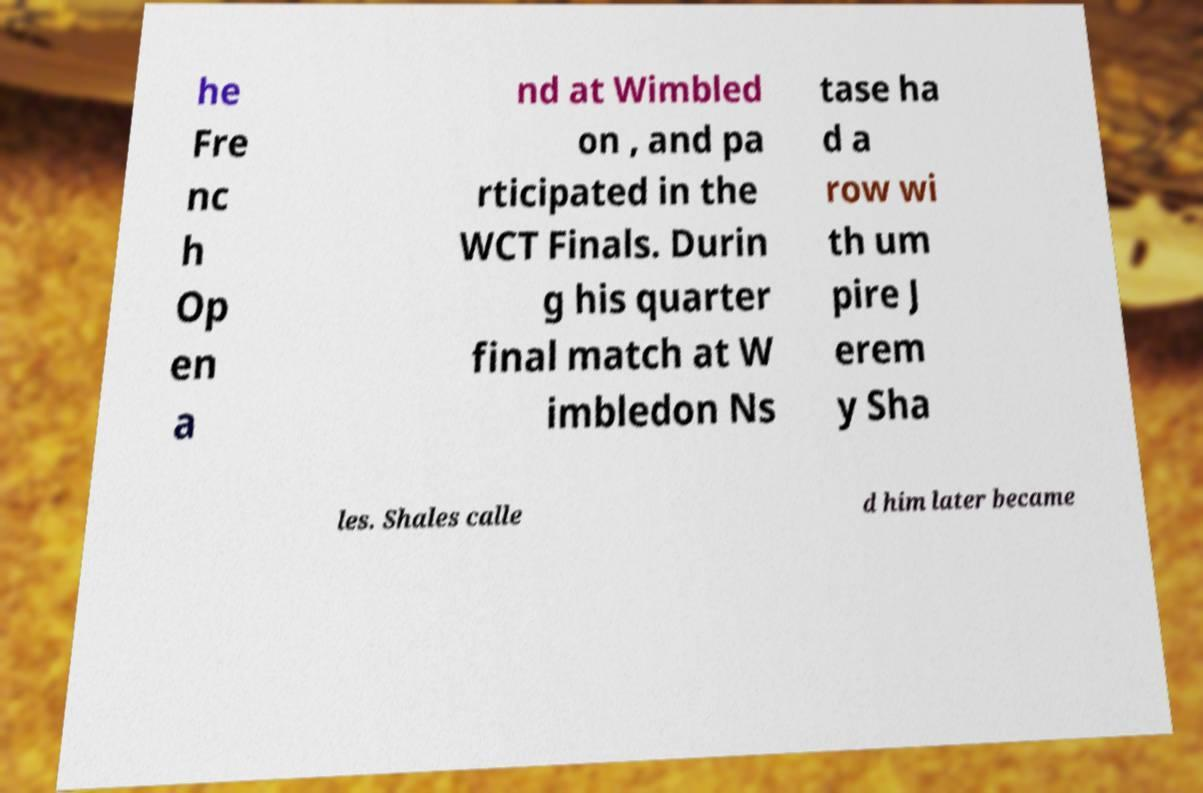There's text embedded in this image that I need extracted. Can you transcribe it verbatim? he Fre nc h Op en a nd at Wimbled on , and pa rticipated in the WCT Finals. Durin g his quarter final match at W imbledon Ns tase ha d a row wi th um pire J erem y Sha les. Shales calle d him later became 